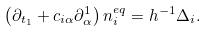Convert formula to latex. <formula><loc_0><loc_0><loc_500><loc_500>\left ( \partial _ { t _ { 1 } } + c _ { i \alpha } \partial _ { \alpha } ^ { 1 } \right ) n _ { i } ^ { e q } = h ^ { - 1 } \Delta _ { i } .</formula> 